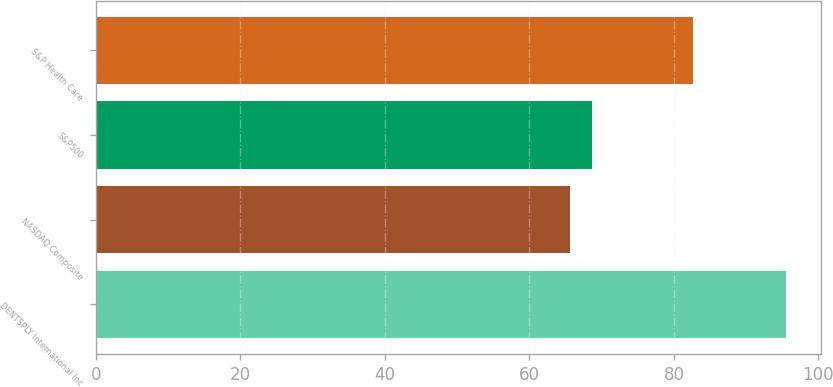Convert chart. <chart><loc_0><loc_0><loc_500><loc_500><bar_chart><fcel>DENTSPLY International Inc<fcel>NASDAQ Composite<fcel>S&P500<fcel>S&P Health Care<nl><fcel>95.52<fcel>65.65<fcel>68.64<fcel>82.71<nl></chart> 